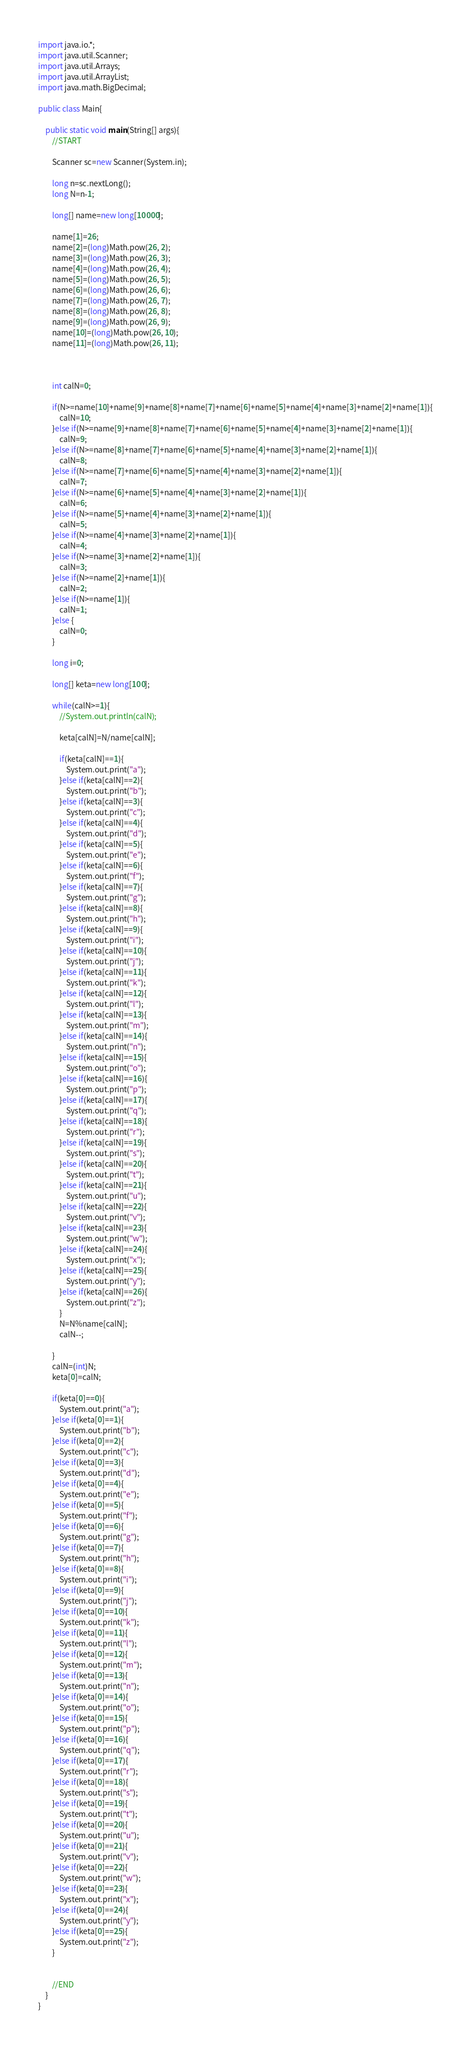Convert code to text. <code><loc_0><loc_0><loc_500><loc_500><_Java_>import java.io.*;
import java.util.Scanner;
import java.util.Arrays;
import java.util.ArrayList;
import java.math.BigDecimal;

public class Main{

    public static void main(String[] args){
        //START

        Scanner sc=new Scanner(System.in);

        long n=sc.nextLong();
        long N=n-1;

        long[] name=new long[10000];

        name[1]=26;
        name[2]=(long)Math.pow(26, 2);
        name[3]=(long)Math.pow(26, 3);
        name[4]=(long)Math.pow(26, 4);
        name[5]=(long)Math.pow(26, 5);
        name[6]=(long)Math.pow(26, 6);
        name[7]=(long)Math.pow(26, 7);
        name[8]=(long)Math.pow(26, 8);
        name[9]=(long)Math.pow(26, 9);
        name[10]=(long)Math.pow(26, 10);
        name[11]=(long)Math.pow(26, 11);



        int calN=0;

        if(N>=name[10]+name[9]+name[8]+name[7]+name[6]+name[5]+name[4]+name[3]+name[2]+name[1]){
            calN=10;
        }else if(N>=name[9]+name[8]+name[7]+name[6]+name[5]+name[4]+name[3]+name[2]+name[1]){
            calN=9;
        }else if(N>=name[8]+name[7]+name[6]+name[5]+name[4]+name[3]+name[2]+name[1]){
            calN=8;
        }else if(N>=name[7]+name[6]+name[5]+name[4]+name[3]+name[2]+name[1]){
            calN=7;
        }else if(N>=name[6]+name[5]+name[4]+name[3]+name[2]+name[1]){
            calN=6;
        }else if(N>=name[5]+name[4]+name[3]+name[2]+name[1]){
            calN=5;
        }else if(N>=name[4]+name[3]+name[2]+name[1]){
            calN=4;
        }else if(N>=name[3]+name[2]+name[1]){
            calN=3;
        }else if(N>=name[2]+name[1]){
            calN=2;
        }else if(N>=name[1]){
            calN=1;
        }else {
            calN=0;
        }

        long i=0;

        long[] keta=new long[100];

        while(calN>=1){
            //System.out.println(calN);

            keta[calN]=N/name[calN];

            if(keta[calN]==1){
                System.out.print("a");
            }else if(keta[calN]==2){
                System.out.print("b");
            }else if(keta[calN]==3){
                System.out.print("c");
            }else if(keta[calN]==4){
                System.out.print("d");
            }else if(keta[calN]==5){
                System.out.print("e");
            }else if(keta[calN]==6){
                System.out.print("f");
            }else if(keta[calN]==7){
                System.out.print("g");
            }else if(keta[calN]==8){
                System.out.print("h");
            }else if(keta[calN]==9){
                System.out.print("i");
            }else if(keta[calN]==10){
                System.out.print("j");
            }else if(keta[calN]==11){
                System.out.print("k");
            }else if(keta[calN]==12){
                System.out.print("l");
            }else if(keta[calN]==13){
                System.out.print("m");
            }else if(keta[calN]==14){
                System.out.print("n");
            }else if(keta[calN]==15){
                System.out.print("o");
            }else if(keta[calN]==16){
                System.out.print("p");
            }else if(keta[calN]==17){
                System.out.print("q");
            }else if(keta[calN]==18){
                System.out.print("r");
            }else if(keta[calN]==19){
                System.out.print("s");
            }else if(keta[calN]==20){
                System.out.print("t");
            }else if(keta[calN]==21){
                System.out.print("u");
            }else if(keta[calN]==22){
                System.out.print("v");
            }else if(keta[calN]==23){
                System.out.print("w");
            }else if(keta[calN]==24){
                System.out.print("x");
            }else if(keta[calN]==25){
                System.out.print("y");
            }else if(keta[calN]==26){
                System.out.print("z");
            }
            N=N%name[calN];
            calN--;

        }
        calN=(int)N;
        keta[0]=calN;

        if(keta[0]==0){
            System.out.print("a");
        }else if(keta[0]==1){
            System.out.print("b");
        }else if(keta[0]==2){
            System.out.print("c");
        }else if(keta[0]==3){
            System.out.print("d");
        }else if(keta[0]==4){
            System.out.print("e");
        }else if(keta[0]==5){
            System.out.print("f");
        }else if(keta[0]==6){
            System.out.print("g");
        }else if(keta[0]==7){
            System.out.print("h");
        }else if(keta[0]==8){
            System.out.print("i");
        }else if(keta[0]==9){
            System.out.print("j");
        }else if(keta[0]==10){
            System.out.print("k");
        }else if(keta[0]==11){
            System.out.print("l");
        }else if(keta[0]==12){
            System.out.print("m");
        }else if(keta[0]==13){
            System.out.print("n");
        }else if(keta[0]==14){
            System.out.print("o");
        }else if(keta[0]==15){
            System.out.print("p");
        }else if(keta[0]==16){
            System.out.print("q");
        }else if(keta[0]==17){
            System.out.print("r");
        }else if(keta[0]==18){
            System.out.print("s");
        }else if(keta[0]==19){
            System.out.print("t");
        }else if(keta[0]==20){
            System.out.print("u");
        }else if(keta[0]==21){
            System.out.print("v");
        }else if(keta[0]==22){
            System.out.print("w");
        }else if(keta[0]==23){
            System.out.print("x");
        }else if(keta[0]==24){
            System.out.print("y");
        }else if(keta[0]==25){
            System.out.print("z");
        }


        //END
    }
}





</code> 